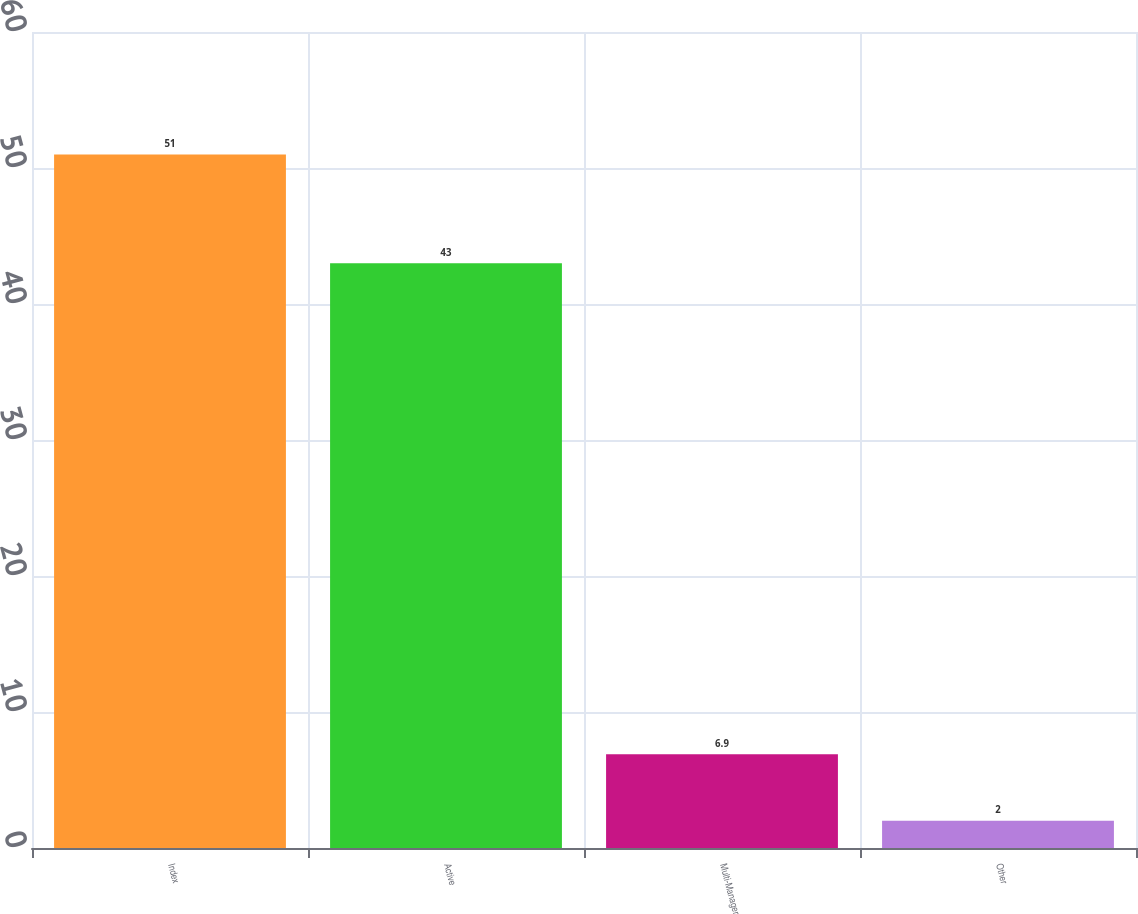Convert chart to OTSL. <chart><loc_0><loc_0><loc_500><loc_500><bar_chart><fcel>Index<fcel>Active<fcel>Multi-Manager<fcel>Other<nl><fcel>51<fcel>43<fcel>6.9<fcel>2<nl></chart> 